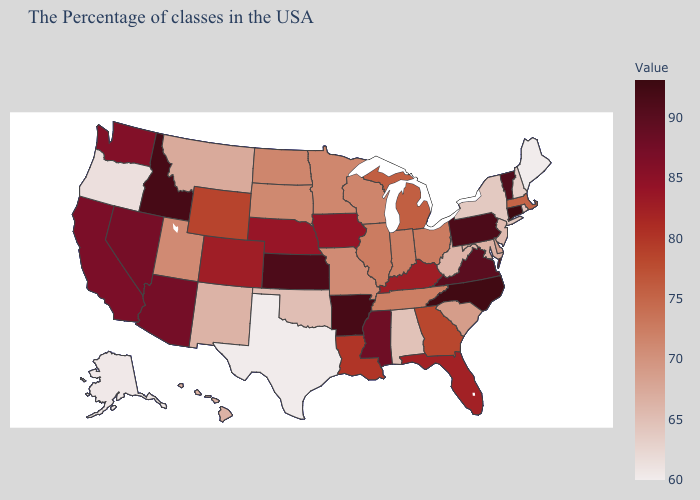Which states have the lowest value in the West?
Quick response, please. Alaska. Does Connecticut have the highest value in the USA?
Give a very brief answer. Yes. Does Mississippi have a lower value than Arkansas?
Short answer required. Yes. Among the states that border Nevada , does California have the lowest value?
Concise answer only. No. 